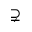Convert formula to latex. <formula><loc_0><loc_0><loc_500><loc_500>\supsetneq</formula> 